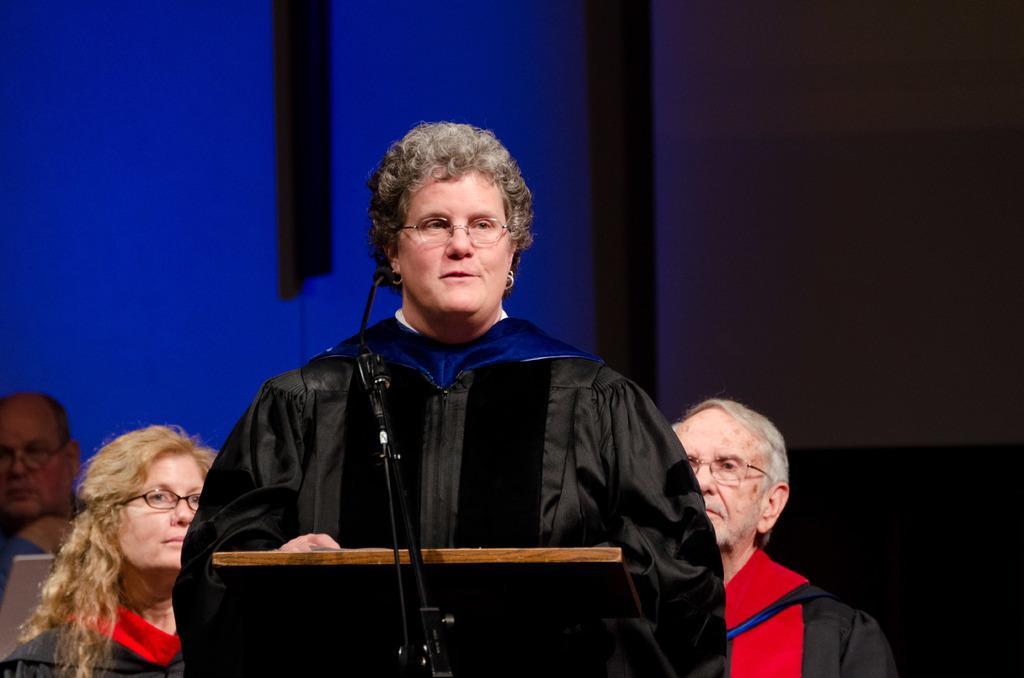Could you give a brief overview of what you see in this image? In this picture I can see a podium in front and I can see the mic. In front of the podium I can see a woman who is wearing black color dress. Behind her I can see 2 men and another woman. I see that it is black and blue color in the background. 